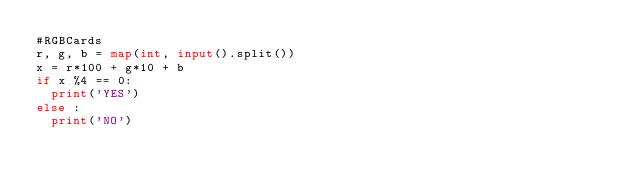Convert code to text. <code><loc_0><loc_0><loc_500><loc_500><_Python_>#RGBCards
r, g, b = map(int, input().split())
x = r*100 + g*10 + b
if x %4 == 0:
  print('YES')
else :
  print('NO')</code> 